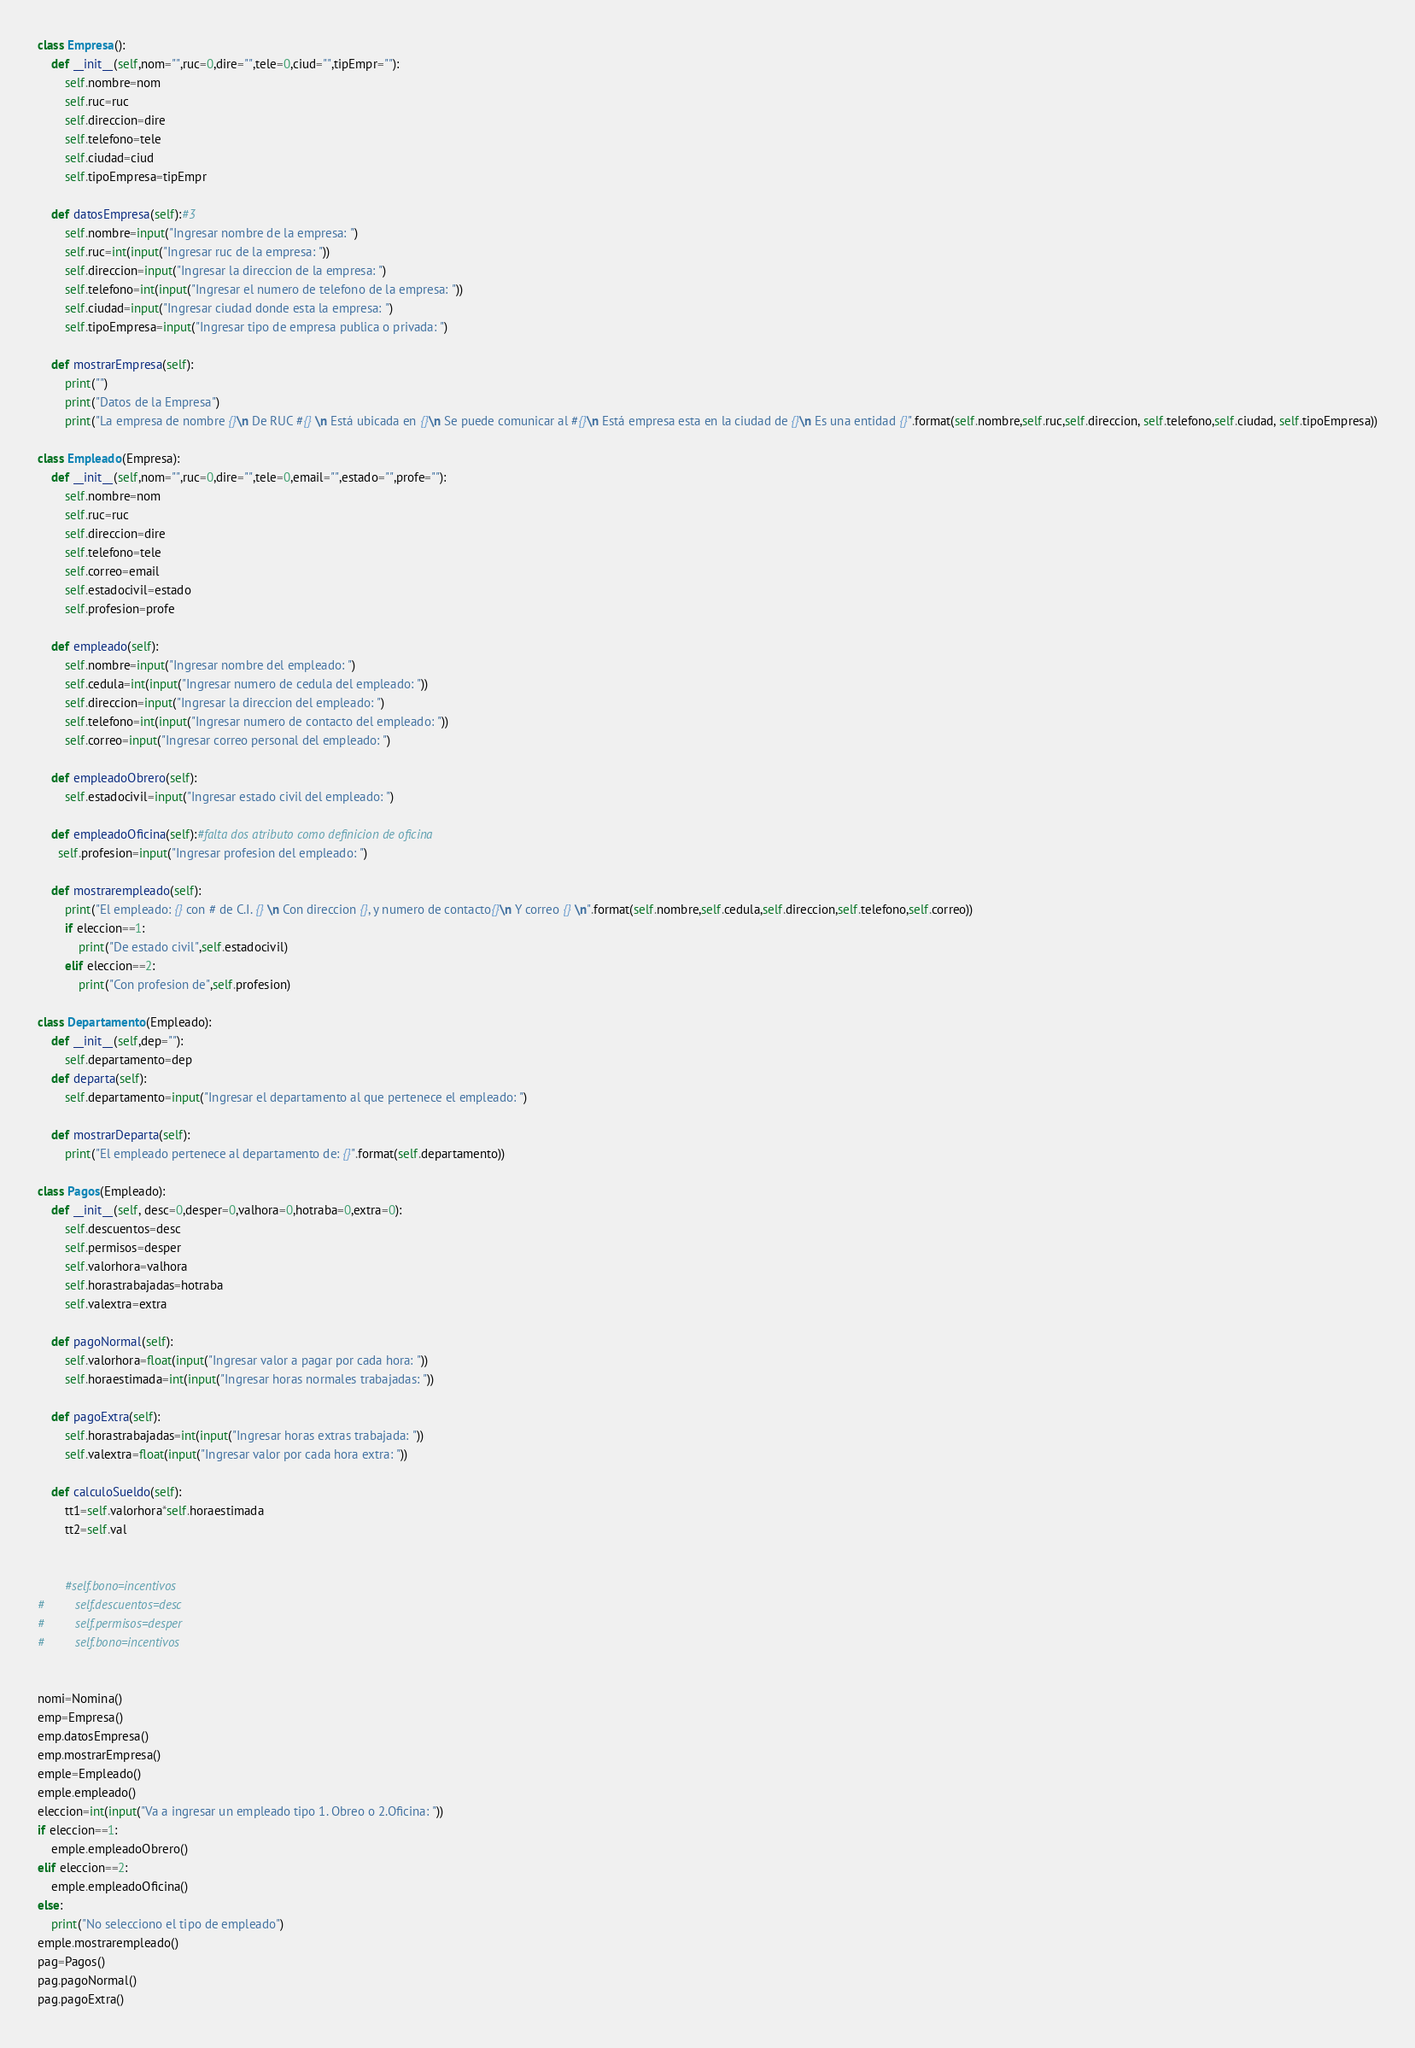<code> <loc_0><loc_0><loc_500><loc_500><_Python_>class Empresa():
    def __init__(self,nom="",ruc=0,dire="",tele=0,ciud="",tipEmpr=""):
        self.nombre=nom
        self.ruc=ruc
        self.direccion=dire
        self.telefono=tele
        self.ciudad=ciud
        self.tipoEmpresa=tipEmpr

    def datosEmpresa(self):#3
        self.nombre=input("Ingresar nombre de la empresa: ")
        self.ruc=int(input("Ingresar ruc de la empresa: "))
        self.direccion=input("Ingresar la direccion de la empresa: ")
        self.telefono=int(input("Ingresar el numero de telefono de la empresa: "))
        self.ciudad=input("Ingresar ciudad donde esta la empresa: ")
        self.tipoEmpresa=input("Ingresar tipo de empresa publica o privada: ")
    
    def mostrarEmpresa(self):
        print("")
        print("Datos de la Empresa")
        print("La empresa de nombre {}\n De RUC #{} \n Está ubicada en {}\n Se puede comunicar al #{}\n Está empresa esta en la ciudad de {}\n Es una entidad {}".format(self.nombre,self.ruc,self.direccion, self.telefono,self.ciudad, self.tipoEmpresa))

class Empleado(Empresa):
    def __init__(self,nom="",ruc=0,dire="",tele=0,email="",estado="",profe=""):
        self.nombre=nom
        self.ruc=ruc
        self.direccion=dire
        self.telefono=tele
        self.correo=email
        self.estadocivil=estado
        self.profesion=profe

    def empleado(self):
        self.nombre=input("Ingresar nombre del empleado: ")
        self.cedula=int(input("Ingresar numero de cedula del empleado: "))
        self.direccion=input("Ingresar la direccion del empleado: ")
        self.telefono=int(input("Ingresar numero de contacto del empleado: "))
        self.correo=input("Ingresar correo personal del empleado: ")

    def empleadoObrero(self): 
        self.estadocivil=input("Ingresar estado civil del empleado: ")

    def empleadoOficina(self):#falta dos atributo como definicion de oficina
      self.profesion=input("Ingresar profesion del empleado: ")

    def mostrarempleado(self):
        print("El empleado: {} con # de C.I. {} \n Con direccion {}, y numero de contacto{}\n Y correo {} \n".format(self.nombre,self.cedula,self.direccion,self.telefono,self.correo))
        if eleccion==1:
            print("De estado civil",self.estadocivil)
        elif eleccion==2:
            print("Con profesion de",self.profesion)  

class Departamento(Empleado):
    def __init__(self,dep=""):
        self.departamento=dep
    def departa(self):
        self.departamento=input("Ingresar el departamento al que pertenece el empleado: ")

    def mostrarDeparta(self):
        print("El empleado pertenece al departamento de: {}".format(self.departamento))

class Pagos(Empleado):
    def __init__(self, desc=0,desper=0,valhora=0,hotraba=0,extra=0):
        self.descuentos=desc
        self.permisos=desper
        self.valorhora=valhora
        self.horastrabajadas=hotraba
        self.valextra=extra

    def pagoNormal(self):
        self.valorhora=float(input("Ingresar valor a pagar por cada hora: "))
        self.horaestimada=int(input("Ingresar horas normales trabajadas: "))
        
    def pagoExtra(self):
        self.horastrabajadas=int(input("Ingresar horas extras trabajada: "))
        self.valextra=float(input("Ingresar valor por cada hora extra: "))

    def calculoSueldo(self):
        tt1=self.valorhora*self.horaestimada
        tt2=self.val


        #self.bono=incentivos
#         self.descuentos=desc
#         self.permisos=desper
#         self.bono=incentivos


nomi=Nomina()
emp=Empresa()
emp.datosEmpresa()
emp.mostrarEmpresa()
emple=Empleado()
emple.empleado()
eleccion=int(input("Va a ingresar un empleado tipo 1. Obreo o 2.Oficina: "))
if eleccion==1:
    emple.empleadoObrero()
elif eleccion==2:
    emple.empleadoOficina()
else:
    print("No selecciono el tipo de empleado")
emple.mostrarempleado()
pag=Pagos()
pag.pagoNormal()
pag.pagoExtra()</code> 